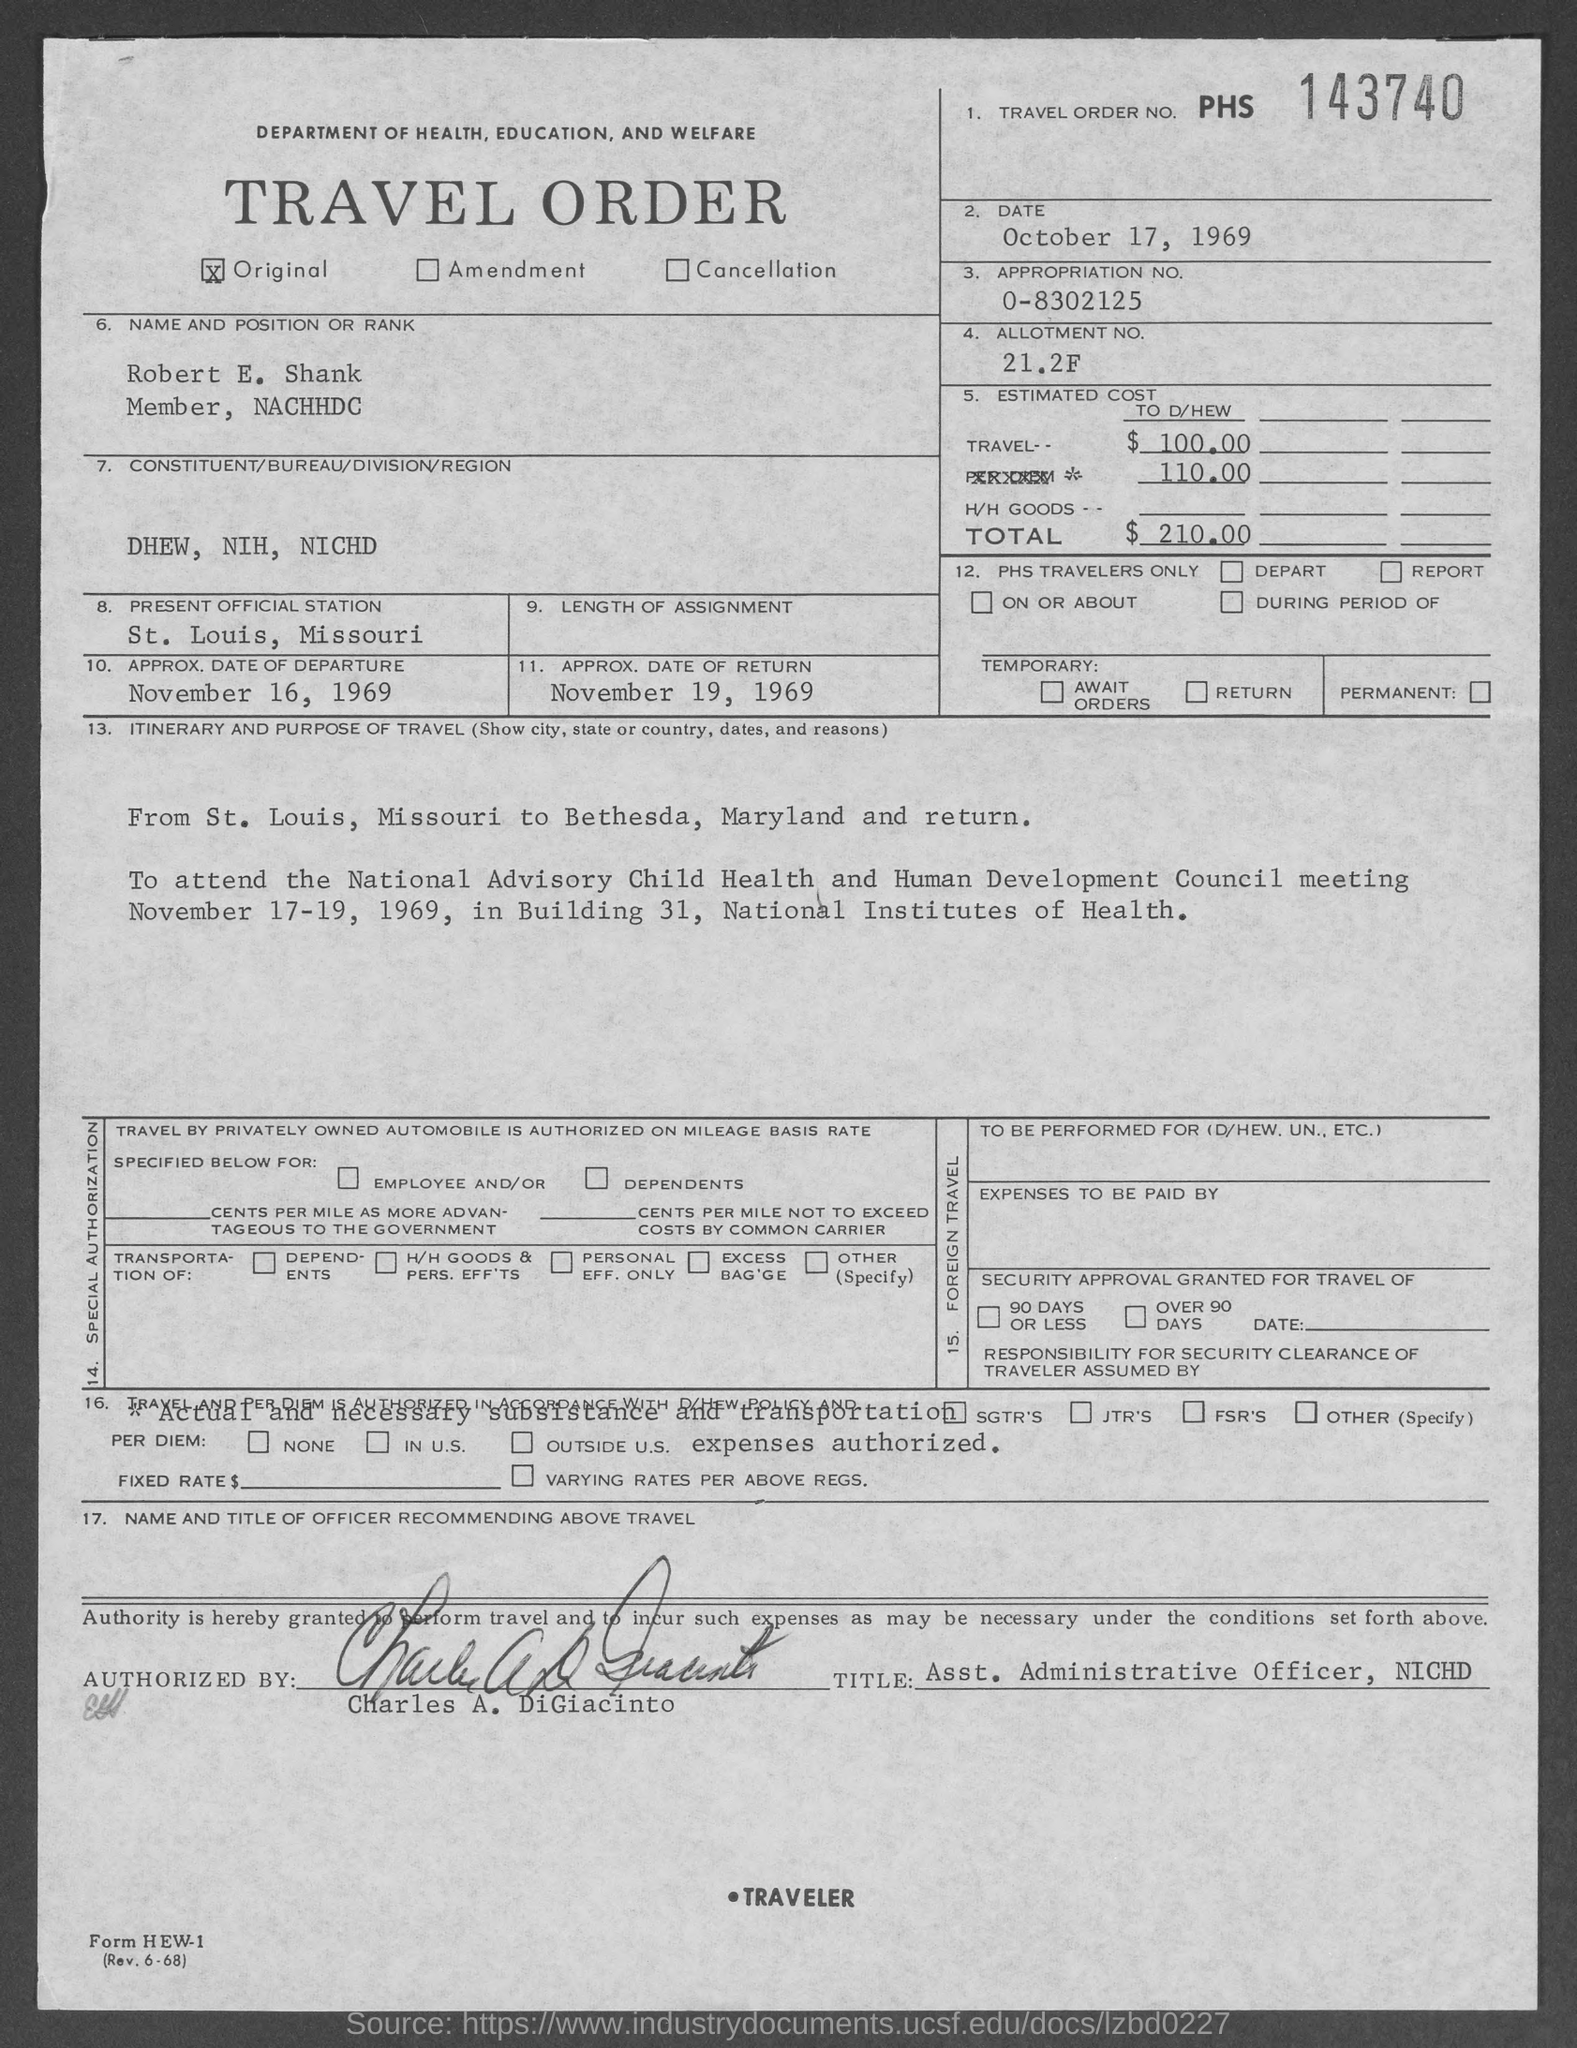What is the appropriation no. mentioned in the given form ?
Your answer should be compact. 0-8302125. What is the allotment no. mentioned in the given form ?
Offer a terse response. 21.2F. What is the name mentioned in the given form ?
Make the answer very short. Robert E. Shank. What is the present official station mentioned in the given form ?
Ensure brevity in your answer.  St. Louis , Missouri. What is the approx. date of departure mentioned in the given form ?
Provide a short and direct response. November 16, 1969. What is the approx. date of return mentioned in the given form ?
Offer a very short reply. November 19, 1969. What is the total amount mentioned in the given form ?
Offer a terse response. $210.00. What is the travel order no. mentioned in the given form ?
Provide a succinct answer. PHS 143740. 